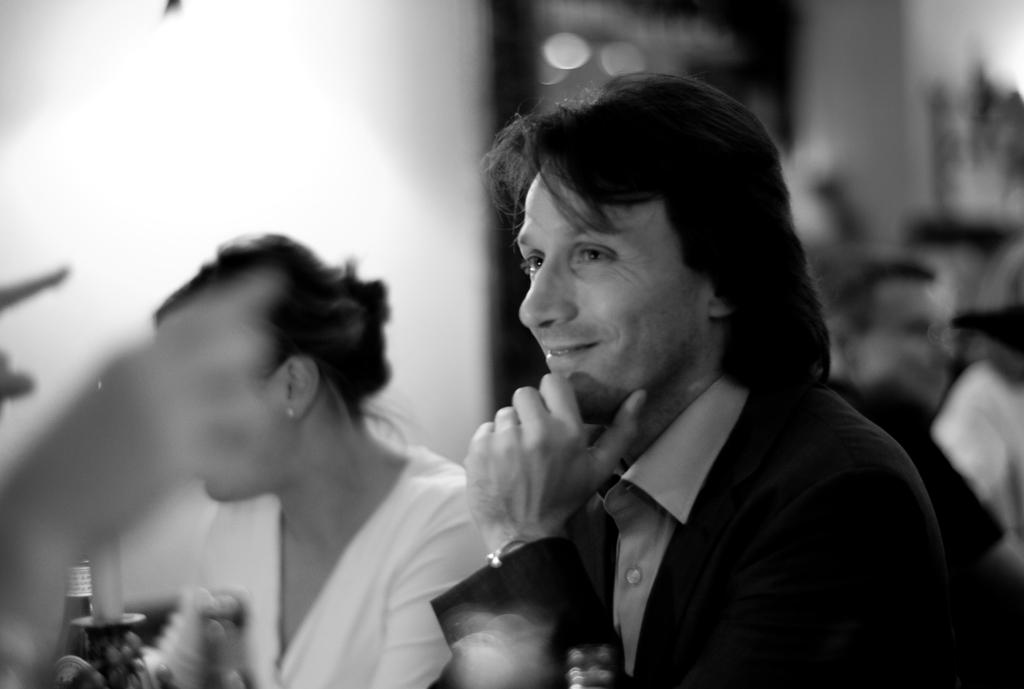What is the color scheme of the image? The image is black and white. Who can be seen in the image? There is a man and a woman in the image. Are there any other people visible in the image? Yes, there are two persons in the background of the image. What type of fiction is the man reading in the image? There is no book or any form of fiction present in the image. 